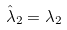<formula> <loc_0><loc_0><loc_500><loc_500>\hat { \lambda } _ { 2 } = \lambda _ { 2 }</formula> 